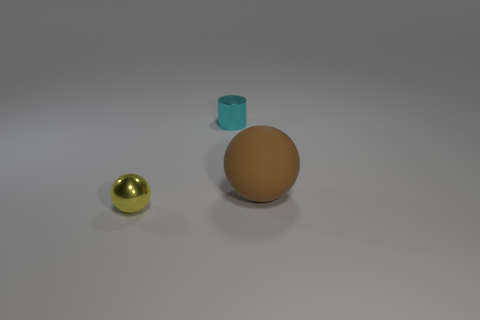There is a metal thing that is the same size as the cyan shiny cylinder; what is its shape?
Your response must be concise. Sphere. Are there any other cyan things of the same shape as the cyan metal thing?
Ensure brevity in your answer.  No. Do the small object on the right side of the tiny ball and the sphere that is in front of the rubber object have the same material?
Provide a short and direct response. Yes. What number of small cylinders have the same material as the small yellow ball?
Offer a very short reply. 1. What is the color of the tiny shiny cylinder?
Give a very brief answer. Cyan. There is a big brown rubber thing on the right side of the tiny metal ball; is its shape the same as the metal object to the right of the yellow sphere?
Offer a very short reply. No. There is a tiny shiny thing that is in front of the brown rubber ball; what is its color?
Make the answer very short. Yellow. Are there fewer small cylinders that are in front of the brown ball than yellow shiny spheres to the left of the small cylinder?
Give a very brief answer. Yes. How many other objects are there of the same material as the large brown sphere?
Offer a very short reply. 0. Are the tiny cylinder and the brown object made of the same material?
Your answer should be compact. No. 